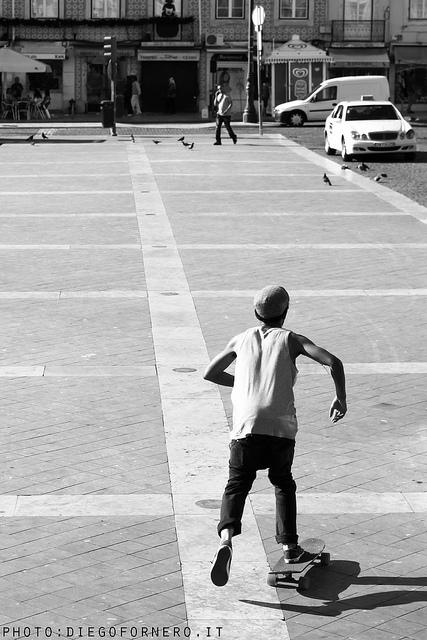What is the boy doing on the skateboard?
Answer briefly. Riding. How many stripes are between the two people?
Be succinct. 9. What website does the photographer want you to visit?
Short answer required. Diegoforneroit. Is this a skate park?
Short answer required. No. 